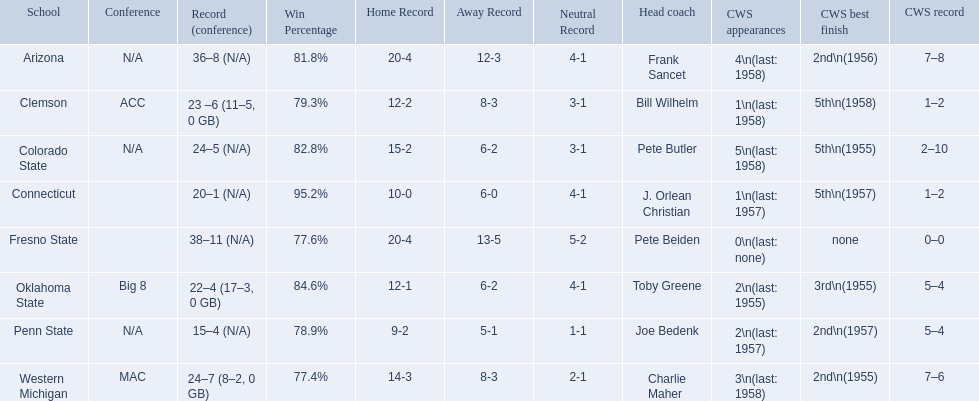What are the teams in the conference? Arizona, Clemson, Colorado State, Connecticut, Fresno State, Oklahoma State, Penn State, Western Michigan. Which have more than 16 wins? Arizona, Clemson, Colorado State, Connecticut, Fresno State, Oklahoma State, Western Michigan. Which had less than 16 wins? Penn State. 